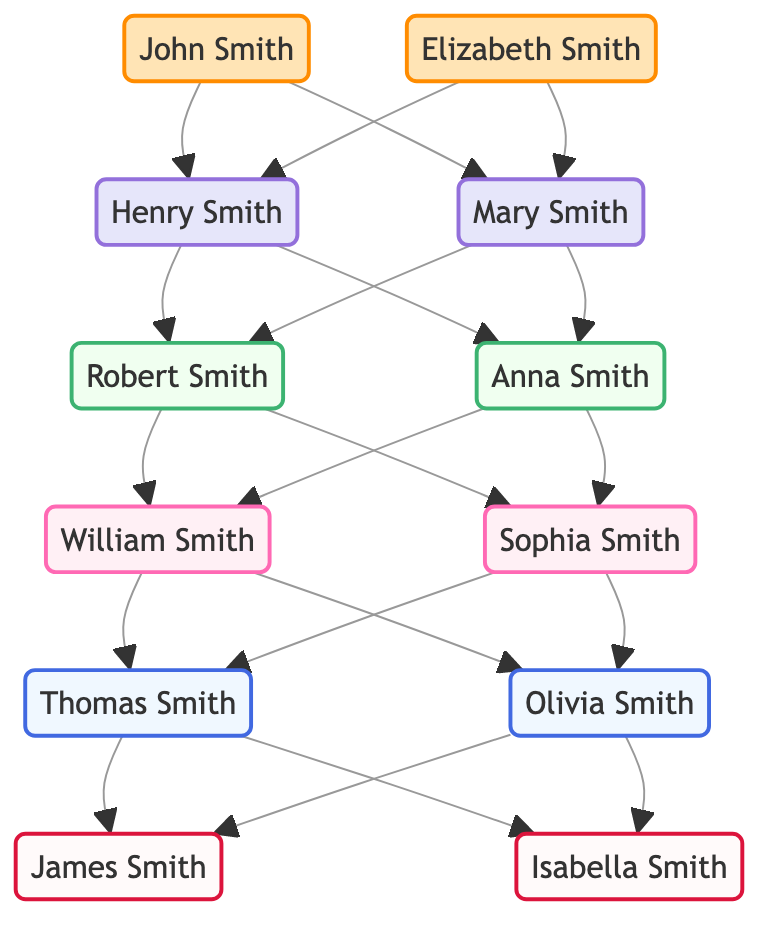What is the total number of generations represented in the diagram? The diagram shows individuals spanning from the first generation (John and Elizabeth Smith) to the sixth generation (James and Isabella Smith). By counting the generations from 1 to 6, we find that there are 6 generations in total.
Answer: 6 Who are the children of Henry Smith? From the diagram, Henry Smith has two children: Robert Smith and Anna Smith. This information can be found by following the arrows (edges) leading from Henry Smith.
Answer: Robert Smith, Anna Smith How many nodes are in the diagram? Counting all the individuals listed in the nodes section, we have 12 distinct individuals represented. This includes John, Elizabeth, Henry, Mary, Robert, Anna, William, Sophia, Thomas, Olivia, James, and Isabella.
Answer: 12 Which individual is the parent of Isabella Smith? The diagram indicates that Thomas Smith and Olivia Smith are both parents of Isabella Smith, as they have direct edges leading to her from both nodes.
Answer: Thomas Smith, Olivia Smith What generation is Sophia Smith in? By checking the generation classification in the diagram, Sophia Smith is listed under generation 4, as denoted by the respective labels assigned to her node.
Answer: 4 How many relationships (edges) connect the generations together in total? By counting all the lines (edges) in the diagram, we find a total of 18 connections representing relationships between parents and children across the generations.
Answer: 18 Who are the grandparents of James Smith? To find the grandparents of James Smith, we trace back to both parents, Thomas and Olivia Smith, and then look at their parents, William and Sophia Smith (from Thomas), and Robert and Anna Smith (from Olivia). Thus, William Smith and Sophia Smith are James's grandparents from one side, and Robert Smith and Anna Smith from the other side.
Answer: William Smith, Sophia Smith, Robert Smith, Anna Smith Which two individuals in the same generation have the most direct relationships? Looking at generation 5, both Thomas Smith and Olivia Smith are connected to James and Isabella Smith, making them siblings in terms of relationships, but they also share parents with multiple direct relationships underneath them, specifically leading to their own children.
Answer: Thomas Smith, Olivia Smith 